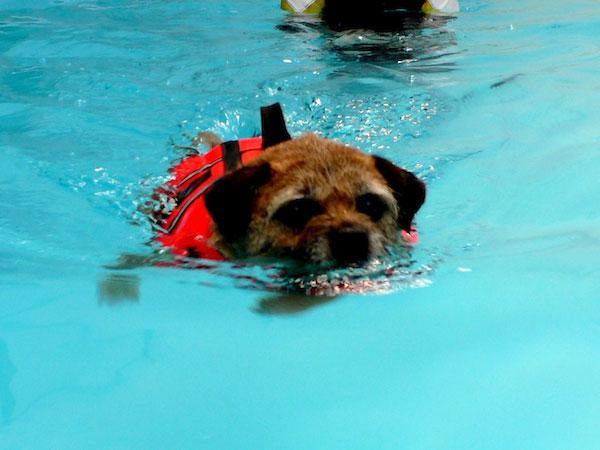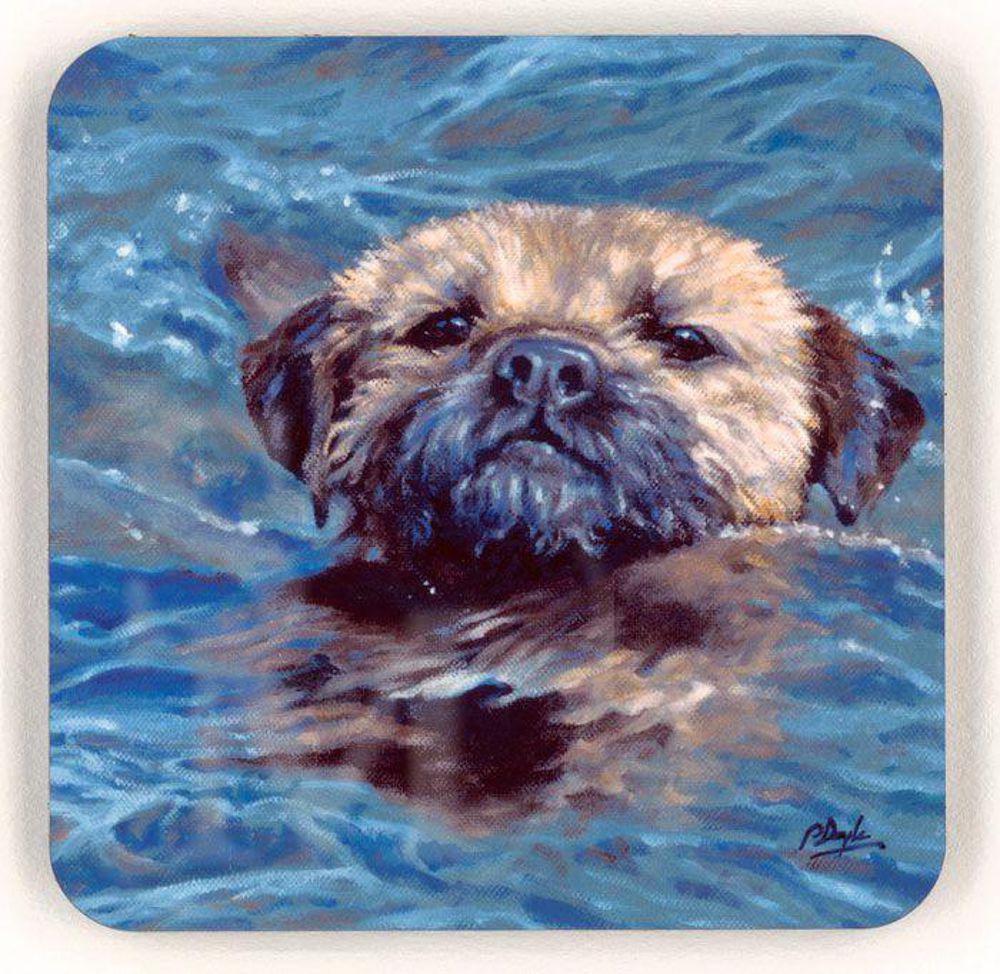The first image is the image on the left, the second image is the image on the right. For the images displayed, is the sentence "A forward-headed dog is staying afloat by means of some item that floats." factually correct? Answer yes or no. Yes. The first image is the image on the left, the second image is the image on the right. For the images shown, is this caption "The dog in the image on the left is swimming in a pool." true? Answer yes or no. Yes. 